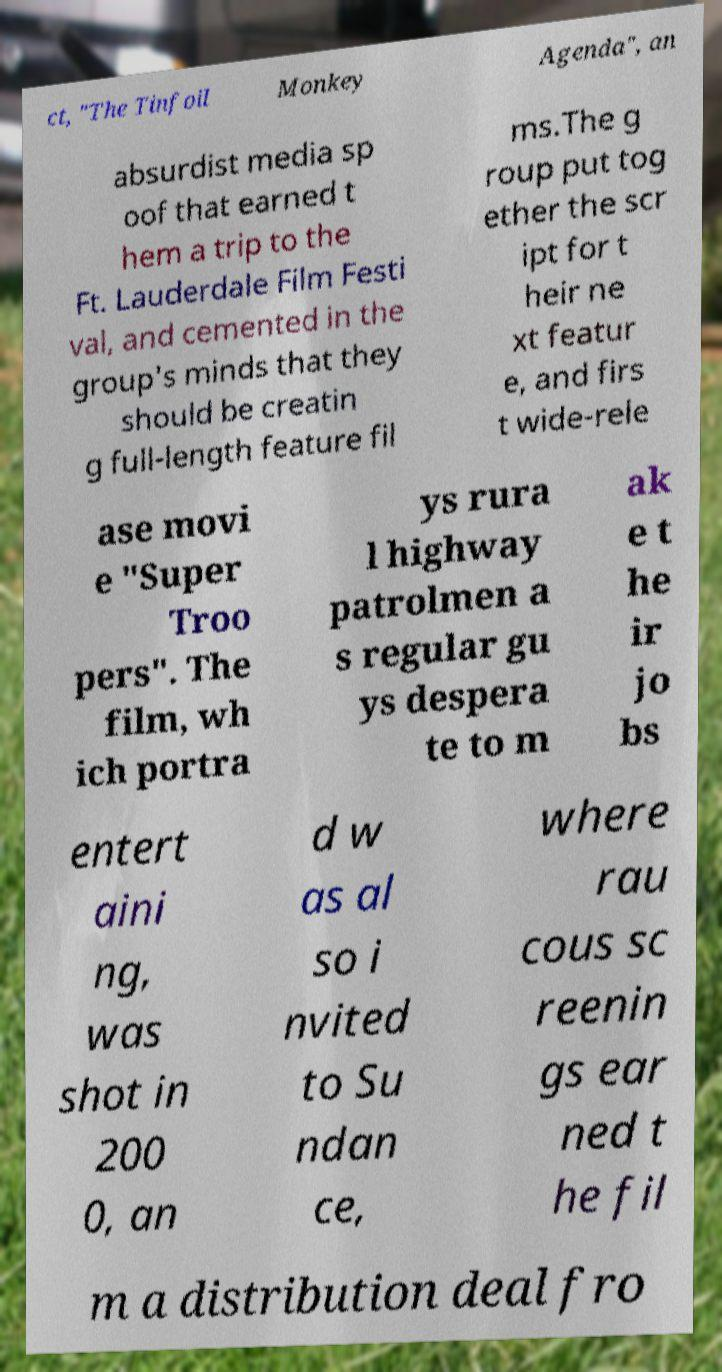Please read and relay the text visible in this image. What does it say? ct, "The Tinfoil Monkey Agenda", an absurdist media sp oof that earned t hem a trip to the Ft. Lauderdale Film Festi val, and cemented in the group's minds that they should be creatin g full-length feature fil ms.The g roup put tog ether the scr ipt for t heir ne xt featur e, and firs t wide-rele ase movi e "Super Troo pers". The film, wh ich portra ys rura l highway patrolmen a s regular gu ys despera te to m ak e t he ir jo bs entert aini ng, was shot in 200 0, an d w as al so i nvited to Su ndan ce, where rau cous sc reenin gs ear ned t he fil m a distribution deal fro 